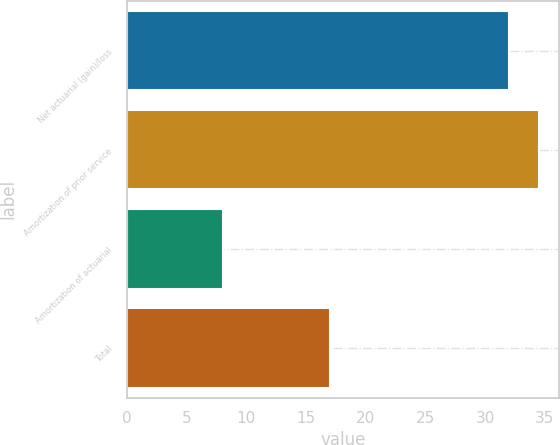Convert chart to OTSL. <chart><loc_0><loc_0><loc_500><loc_500><bar_chart><fcel>Net actuarial (gain)/loss<fcel>Amortization of prior service<fcel>Amortization of actuarial<fcel>Total<nl><fcel>32<fcel>34.5<fcel>8<fcel>17<nl></chart> 